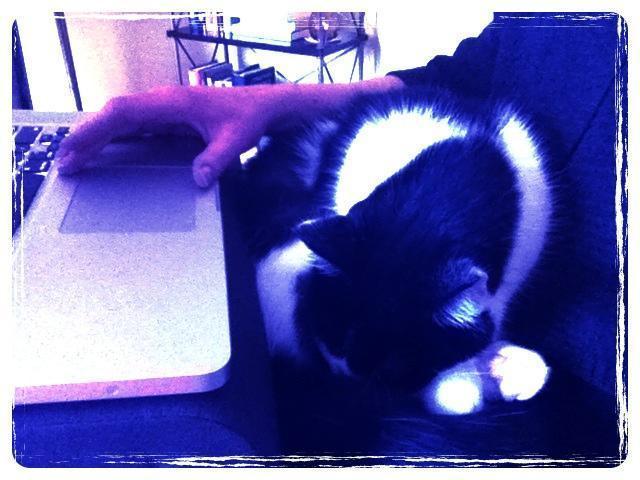How many baby sheep are there?
Give a very brief answer. 0. 